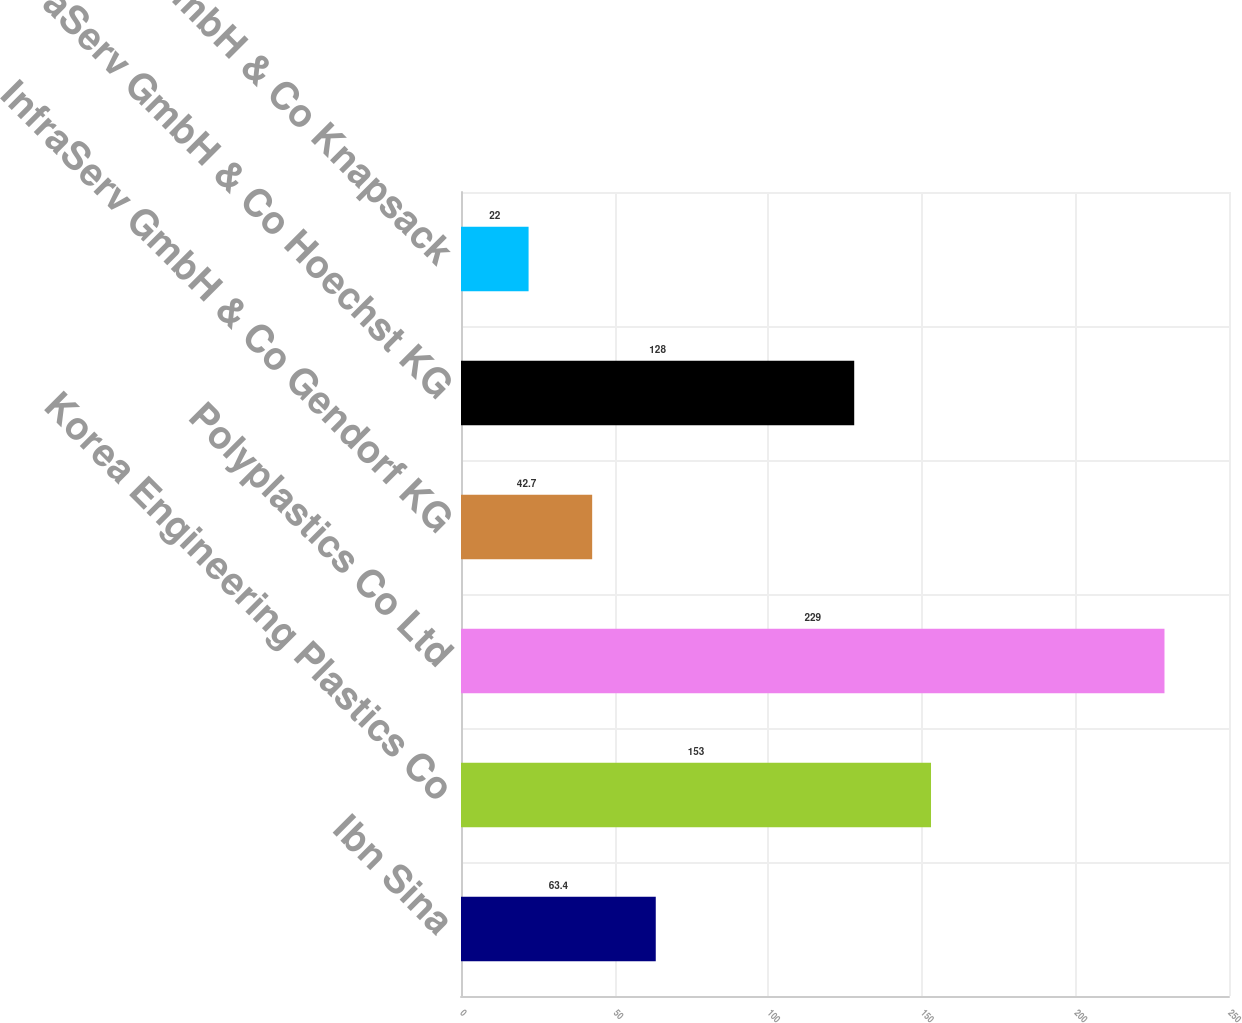<chart> <loc_0><loc_0><loc_500><loc_500><bar_chart><fcel>Ibn Sina<fcel>Korea Engineering Plastics Co<fcel>Polyplastics Co Ltd<fcel>InfraServ GmbH & Co Gendorf KG<fcel>InfraServ GmbH & Co Hoechst KG<fcel>InfraServ GmbH & Co Knapsack<nl><fcel>63.4<fcel>153<fcel>229<fcel>42.7<fcel>128<fcel>22<nl></chart> 